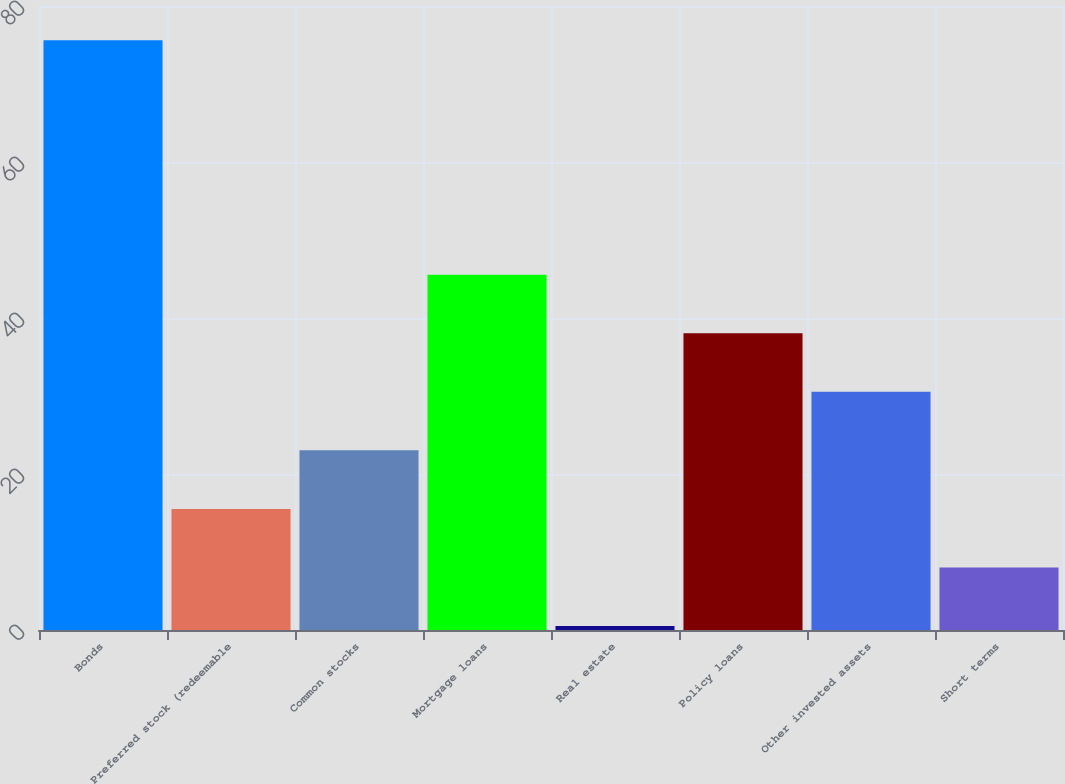Convert chart to OTSL. <chart><loc_0><loc_0><loc_500><loc_500><bar_chart><fcel>Bonds<fcel>Preferred stock (redeemable<fcel>Common stocks<fcel>Mortgage loans<fcel>Real estate<fcel>Policy loans<fcel>Other invested assets<fcel>Short terms<nl><fcel>75.6<fcel>15.52<fcel>23.03<fcel>45.56<fcel>0.5<fcel>38.05<fcel>30.54<fcel>8.01<nl></chart> 